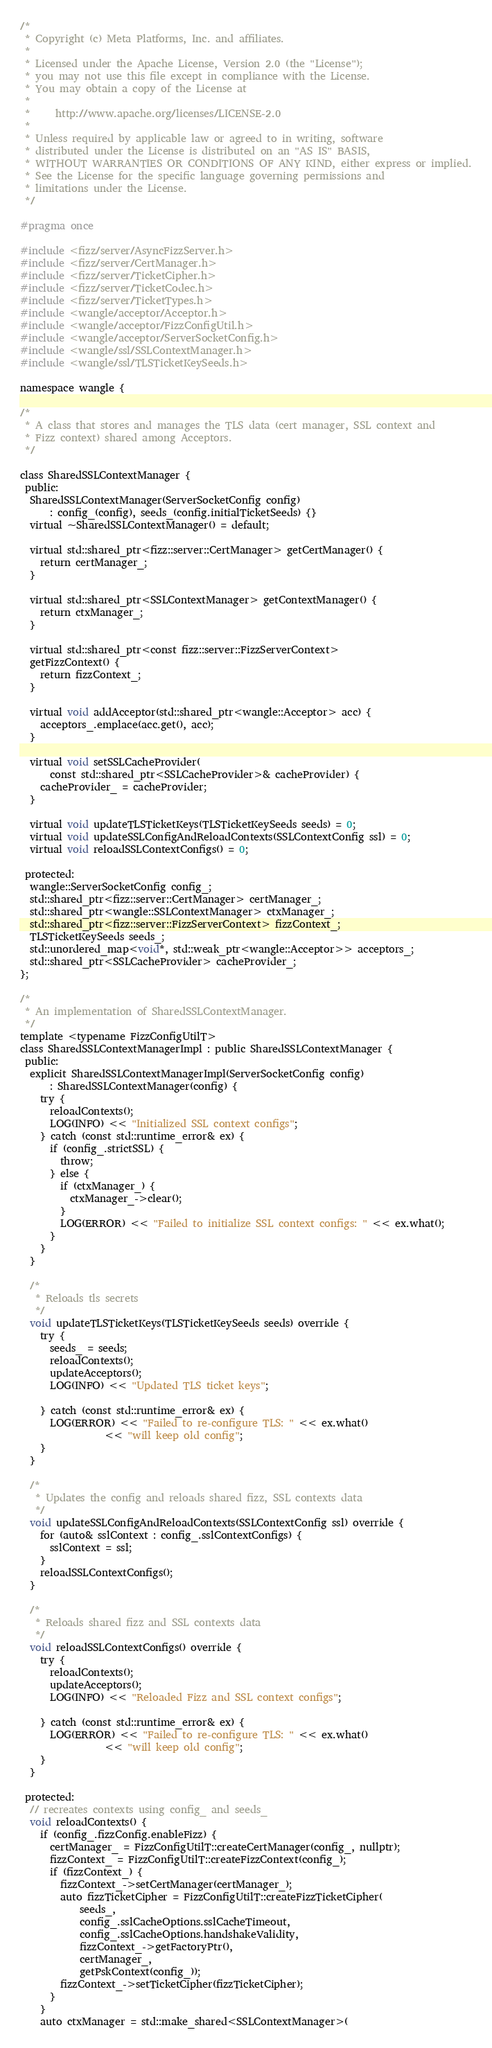<code> <loc_0><loc_0><loc_500><loc_500><_C_>/*
 * Copyright (c) Meta Platforms, Inc. and affiliates.
 *
 * Licensed under the Apache License, Version 2.0 (the "License");
 * you may not use this file except in compliance with the License.
 * You may obtain a copy of the License at
 *
 *     http://www.apache.org/licenses/LICENSE-2.0
 *
 * Unless required by applicable law or agreed to in writing, software
 * distributed under the License is distributed on an "AS IS" BASIS,
 * WITHOUT WARRANTIES OR CONDITIONS OF ANY KIND, either express or implied.
 * See the License for the specific language governing permissions and
 * limitations under the License.
 */

#pragma once

#include <fizz/server/AsyncFizzServer.h>
#include <fizz/server/CertManager.h>
#include <fizz/server/TicketCipher.h>
#include <fizz/server/TicketCodec.h>
#include <fizz/server/TicketTypes.h>
#include <wangle/acceptor/Acceptor.h>
#include <wangle/acceptor/FizzConfigUtil.h>
#include <wangle/acceptor/ServerSocketConfig.h>
#include <wangle/ssl/SSLContextManager.h>
#include <wangle/ssl/TLSTicketKeySeeds.h>

namespace wangle {

/*
 * A class that stores and manages the TLS data (cert manager, SSL context and
 * Fizz context) shared among Acceptors.
 */

class SharedSSLContextManager {
 public:
  SharedSSLContextManager(ServerSocketConfig config)
      : config_(config), seeds_(config.initialTicketSeeds) {}
  virtual ~SharedSSLContextManager() = default;

  virtual std::shared_ptr<fizz::server::CertManager> getCertManager() {
    return certManager_;
  }

  virtual std::shared_ptr<SSLContextManager> getContextManager() {
    return ctxManager_;
  }

  virtual std::shared_ptr<const fizz::server::FizzServerContext>
  getFizzContext() {
    return fizzContext_;
  }

  virtual void addAcceptor(std::shared_ptr<wangle::Acceptor> acc) {
    acceptors_.emplace(acc.get(), acc);
  }

  virtual void setSSLCacheProvider(
      const std::shared_ptr<SSLCacheProvider>& cacheProvider) {
    cacheProvider_ = cacheProvider;
  }

  virtual void updateTLSTicketKeys(TLSTicketKeySeeds seeds) = 0;
  virtual void updateSSLConfigAndReloadContexts(SSLContextConfig ssl) = 0;
  virtual void reloadSSLContextConfigs() = 0;

 protected:
  wangle::ServerSocketConfig config_;
  std::shared_ptr<fizz::server::CertManager> certManager_;
  std::shared_ptr<wangle::SSLContextManager> ctxManager_;
  std::shared_ptr<fizz::server::FizzServerContext> fizzContext_;
  TLSTicketKeySeeds seeds_;
  std::unordered_map<void*, std::weak_ptr<wangle::Acceptor>> acceptors_;
  std::shared_ptr<SSLCacheProvider> cacheProvider_;
};

/*
 * An implementation of SharedSSLContextManager.
 */
template <typename FizzConfigUtilT>
class SharedSSLContextManagerImpl : public SharedSSLContextManager {
 public:
  explicit SharedSSLContextManagerImpl(ServerSocketConfig config)
      : SharedSSLContextManager(config) {
    try {
      reloadContexts();
      LOG(INFO) << "Initialized SSL context configs";
    } catch (const std::runtime_error& ex) {
      if (config_.strictSSL) {
        throw;
      } else {
        if (ctxManager_) {
          ctxManager_->clear();
        }
        LOG(ERROR) << "Failed to initialize SSL context configs: " << ex.what();
      }
    }
  }

  /*
   * Reloads tls secrets
   */
  void updateTLSTicketKeys(TLSTicketKeySeeds seeds) override {
    try {
      seeds_ = seeds;
      reloadContexts();
      updateAcceptors();
      LOG(INFO) << "Updated TLS ticket keys";

    } catch (const std::runtime_error& ex) {
      LOG(ERROR) << "Failed to re-configure TLS: " << ex.what()
                 << "will keep old config";
    }
  }

  /*
   * Updates the config and reloads shared fizz, SSL contexts data
   */
  void updateSSLConfigAndReloadContexts(SSLContextConfig ssl) override {
    for (auto& sslContext : config_.sslContextConfigs) {
      sslContext = ssl;
    }
    reloadSSLContextConfigs();
  }

  /*
   * Reloads shared fizz and SSL contexts data
   */
  void reloadSSLContextConfigs() override {
    try {
      reloadContexts();
      updateAcceptors();
      LOG(INFO) << "Reloaded Fizz and SSL context configs";

    } catch (const std::runtime_error& ex) {
      LOG(ERROR) << "Failed to re-configure TLS: " << ex.what()
                 << "will keep old config";
    }
  }

 protected:
  // recreates contexts using config_ and seeds_
  void reloadContexts() {
    if (config_.fizzConfig.enableFizz) {
      certManager_ = FizzConfigUtilT::createCertManager(config_, nullptr);
      fizzContext_ = FizzConfigUtilT::createFizzContext(config_);
      if (fizzContext_) {
        fizzContext_->setCertManager(certManager_);
        auto fizzTicketCipher = FizzConfigUtilT::createFizzTicketCipher(
            seeds_,
            config_.sslCacheOptions.sslCacheTimeout,
            config_.sslCacheOptions.handshakeValidity,
            fizzContext_->getFactoryPtr(),
            certManager_,
            getPskContext(config_));
        fizzContext_->setTicketCipher(fizzTicketCipher);
      }
    }
    auto ctxManager = std::make_shared<SSLContextManager>(</code> 